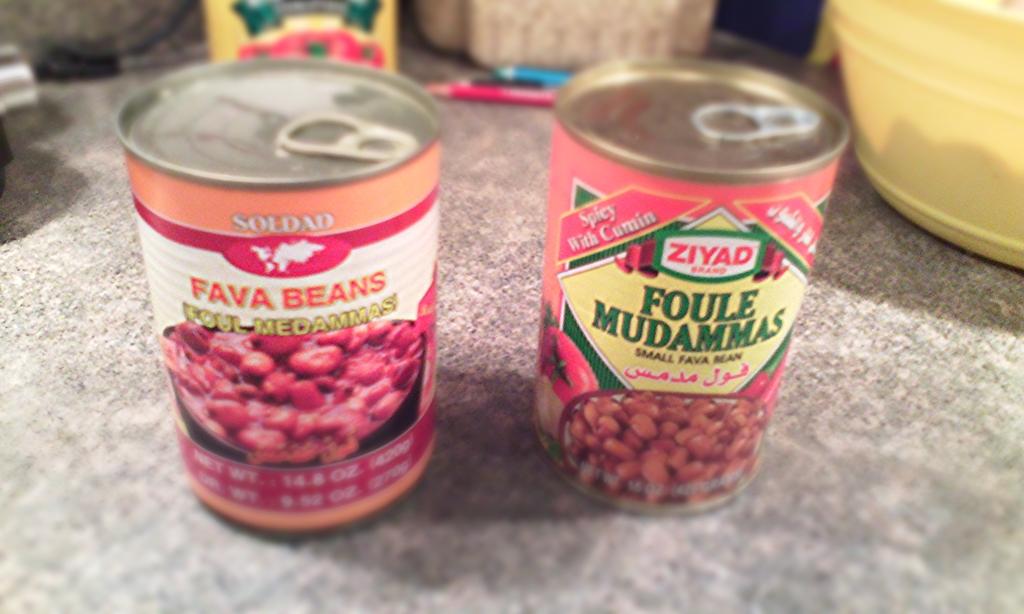What is the brand to the left?
Offer a very short reply. Soldad. 